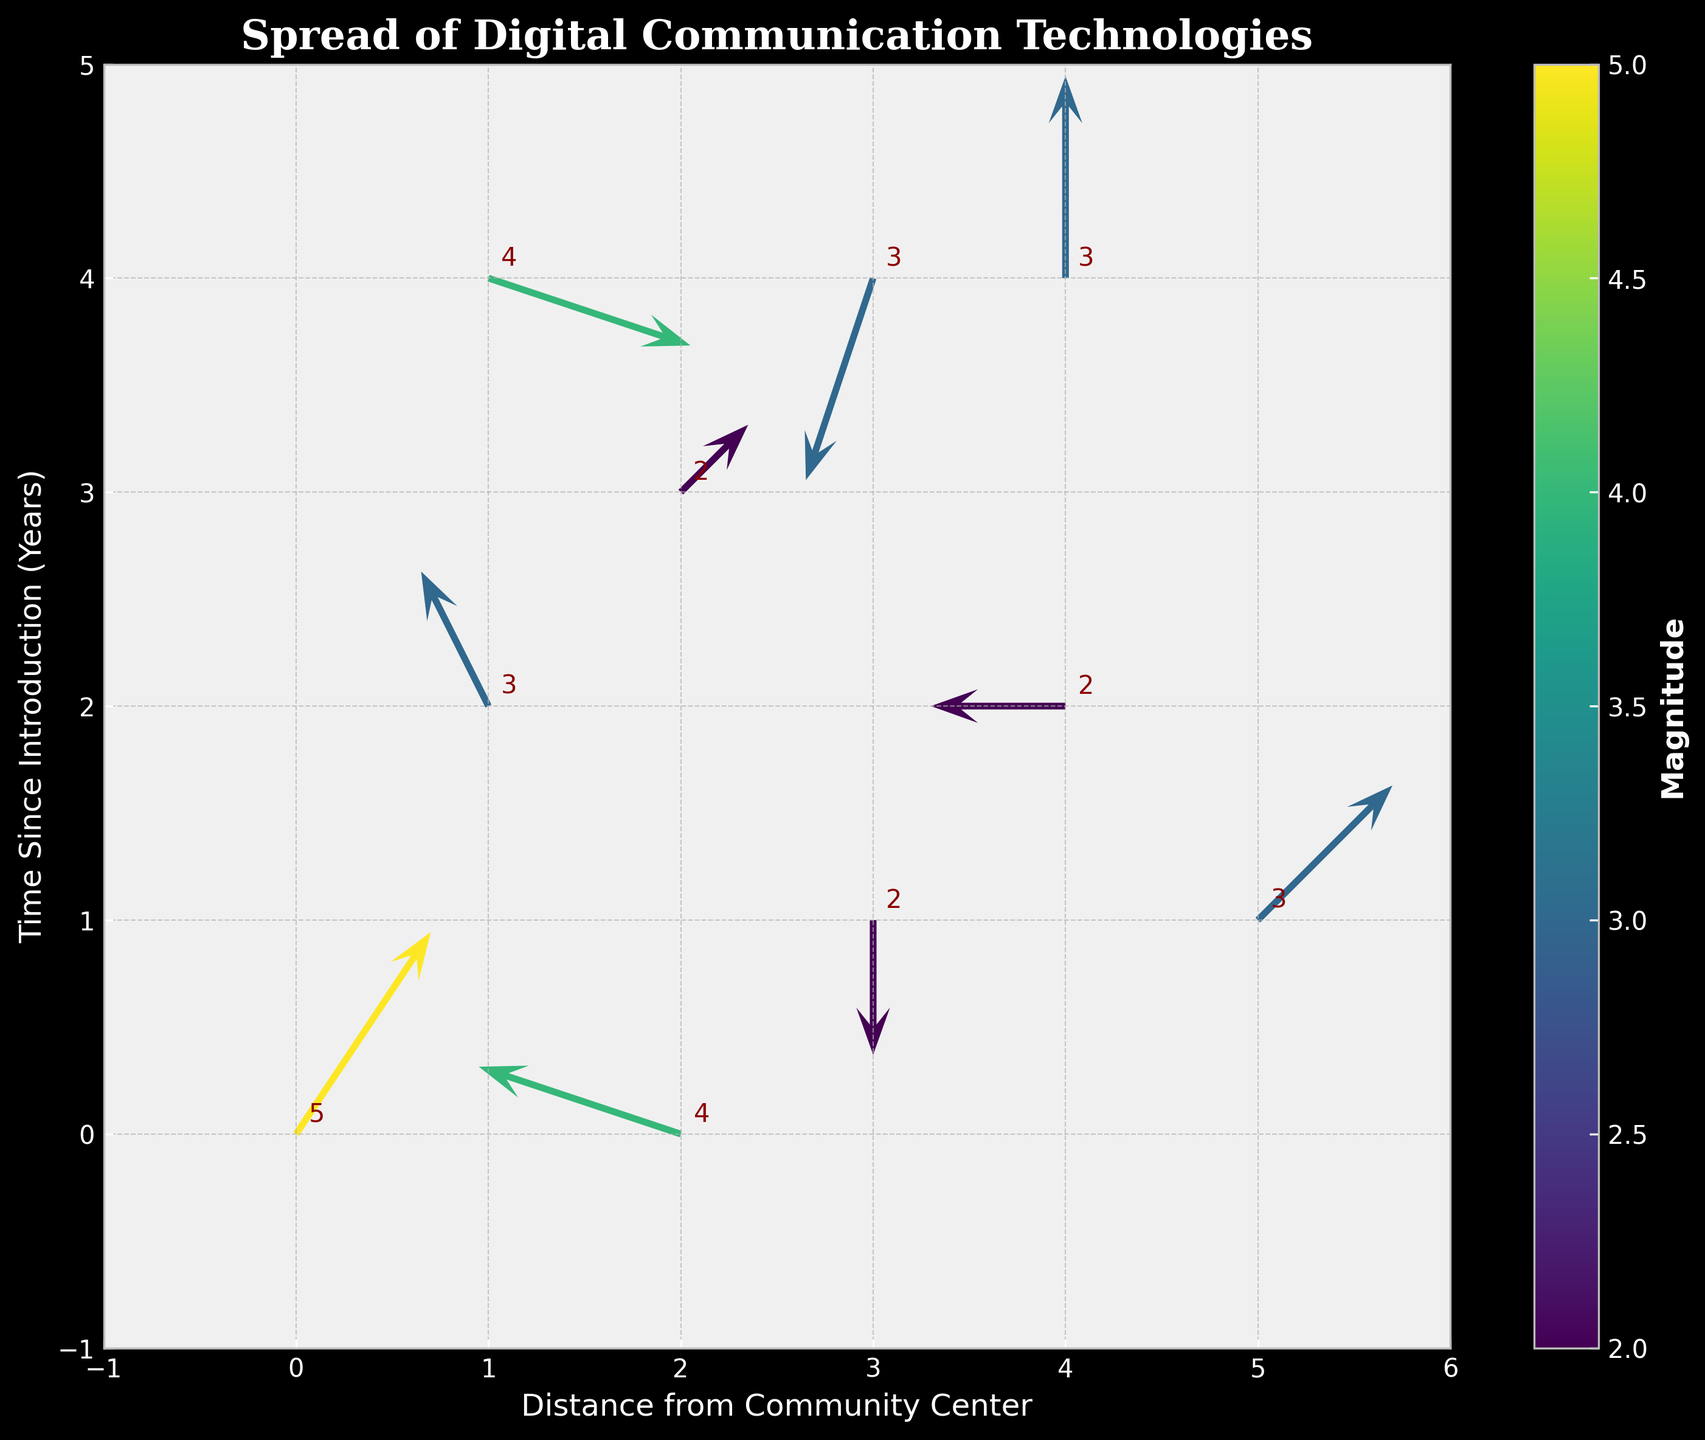What is the title of the plot? The title is displayed at the top of the plot.
Answer: Spread of Digital Communication Technologies How many arrows are there in the plot? Count the number of arrows in the plot. There are a total of 10 arrows.
Answer: 10 Which direction does the arrow at (1, 2) point? Look at the arrow located at the coordinates (1, 2). Its direction is determined by its (u, v) components, which are (-1, 2). This means it points left and slightly upwards.
Answer: Left-upwards What's the value of the magnitude at (4, 4)? Find the arrow located at (4, 4) and look at its corresponding magnitude value, which is displayed next to the arrow.
Answer: 3 Which arrow has the highest magnitude? Compare all the magnitude values of the arrows to find the highest value. The highest magnitude value is 5, located at (0, 0).
Answer: (0, 0) What is the average of the magnitudes depicted in the plot? Sum all the magnitudes (5 + 3 + 2 + 2 + 2 + 4 + 3 + 3 + 4 + 3 = 31) and then divide by the number of arrows (10).
Answer: 3.1 Which arrows have a downward component in their direction? Identify arrows with negative v values as they indicate downward direction components. These arrows are located at (3, 1), (1, 4), (3, 4).
Answer: (3, 1), (1, 4), (3, 4) What is the color of the arrows with the highest magnitude? The color of arrows corresponds to their magnitude using a colormap. Higher magnitudes are depicted in lighter colors, such as yellow in the 'viridis' colormap, which is the color of the arrow at (0, 0).
Answer: Yellow How far is the arrow at (5, 1) from the community center? The distance can be derived by considering the x-axis as representing distance from the community center. The arrow at (5, 1) is 5 units away from the community center.
Answer: 5 units In which direction does the majority of arrows point? Evaluate the direction vectors (u, v) of each arrow and determine the most common directional trend. Majority of arrows tend to point either upwards or with an upward component.
Answer: Upwards 